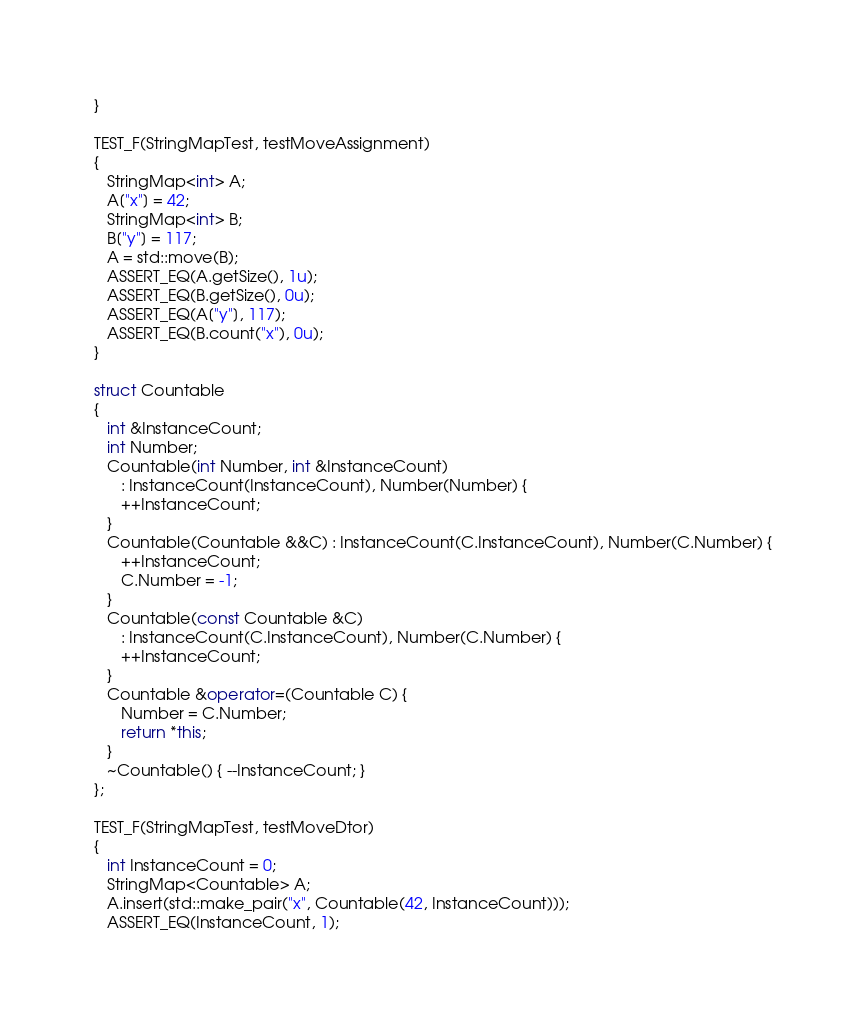<code> <loc_0><loc_0><loc_500><loc_500><_C++_>}

TEST_F(StringMapTest, testMoveAssignment)
{
   StringMap<int> A;
   A["x"] = 42;
   StringMap<int> B;
   B["y"] = 117;
   A = std::move(B);
   ASSERT_EQ(A.getSize(), 1u);
   ASSERT_EQ(B.getSize(), 0u);
   ASSERT_EQ(A["y"], 117);
   ASSERT_EQ(B.count("x"), 0u);
}

struct Countable
{
   int &InstanceCount;
   int Number;
   Countable(int Number, int &InstanceCount)
      : InstanceCount(InstanceCount), Number(Number) {
      ++InstanceCount;
   }
   Countable(Countable &&C) : InstanceCount(C.InstanceCount), Number(C.Number) {
      ++InstanceCount;
      C.Number = -1;
   }
   Countable(const Countable &C)
      : InstanceCount(C.InstanceCount), Number(C.Number) {
      ++InstanceCount;
   }
   Countable &operator=(Countable C) {
      Number = C.Number;
      return *this;
   }
   ~Countable() { --InstanceCount; }
};

TEST_F(StringMapTest, testMoveDtor)
{
   int InstanceCount = 0;
   StringMap<Countable> A;
   A.insert(std::make_pair("x", Countable(42, InstanceCount)));
   ASSERT_EQ(InstanceCount, 1);</code> 